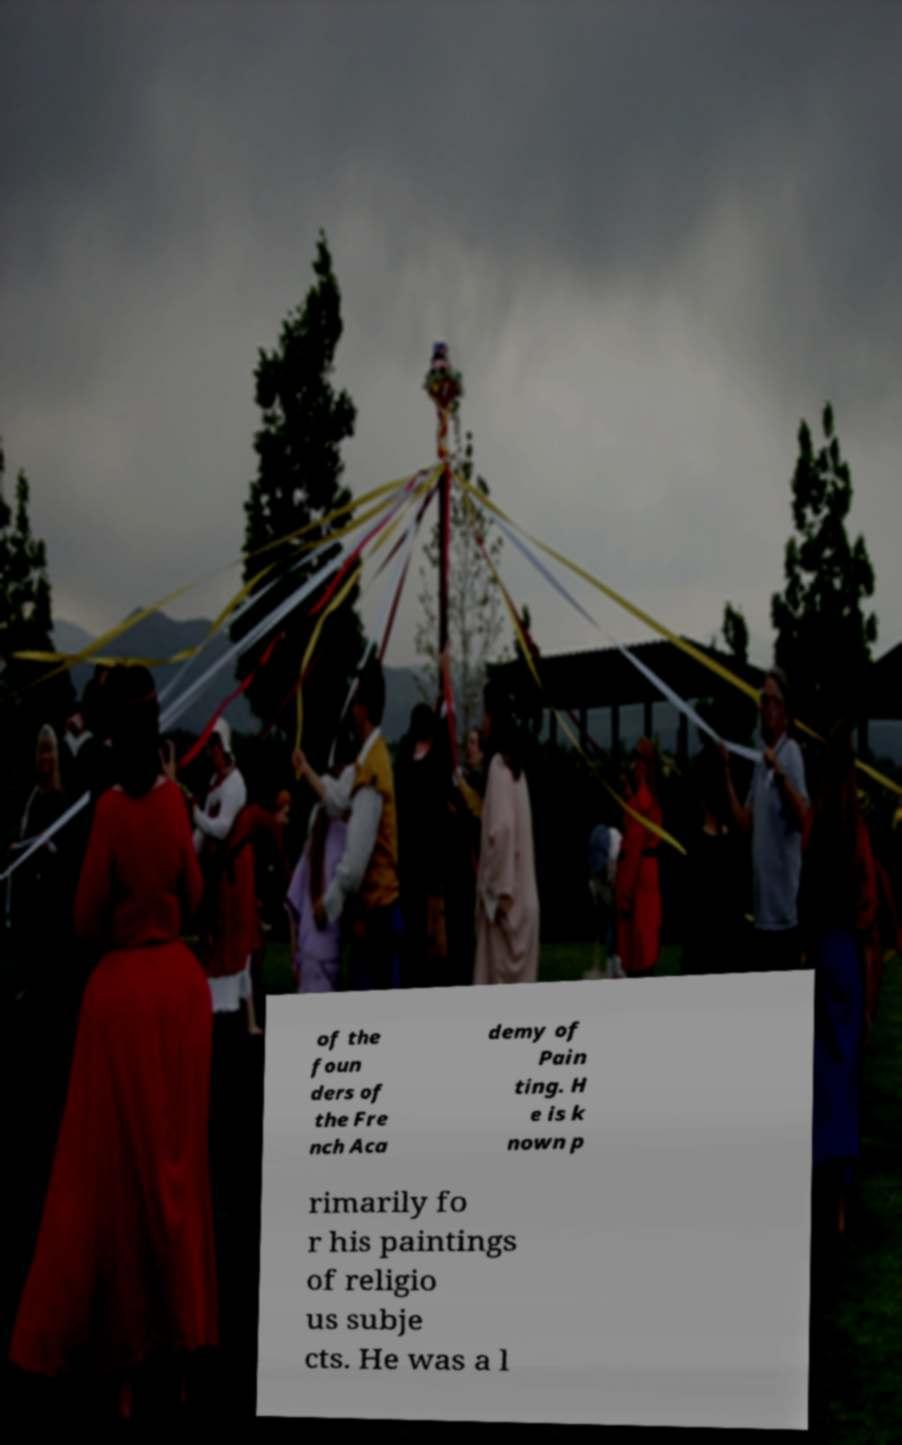Can you accurately transcribe the text from the provided image for me? of the foun ders of the Fre nch Aca demy of Pain ting. H e is k nown p rimarily fo r his paintings of religio us subje cts. He was a l 